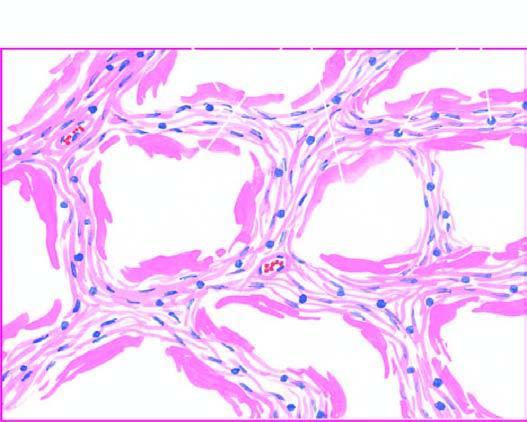re part of the endocervical mucosa alternate areas of collapsed and dilated alveolar spaces, many of which are lined by eosinophilic hyaline membranes?
Answer the question using a single word or phrase. No 